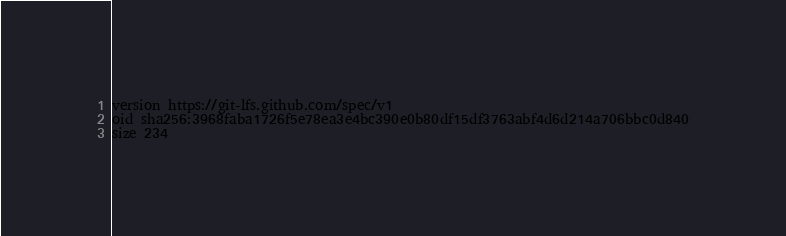<code> <loc_0><loc_0><loc_500><loc_500><_YAML_>version https://git-lfs.github.com/spec/v1
oid sha256:3968faba1726f5e78ea3e4bc390e0b80df15df3763abf4d6d214a706bbc0d840
size 234
</code> 